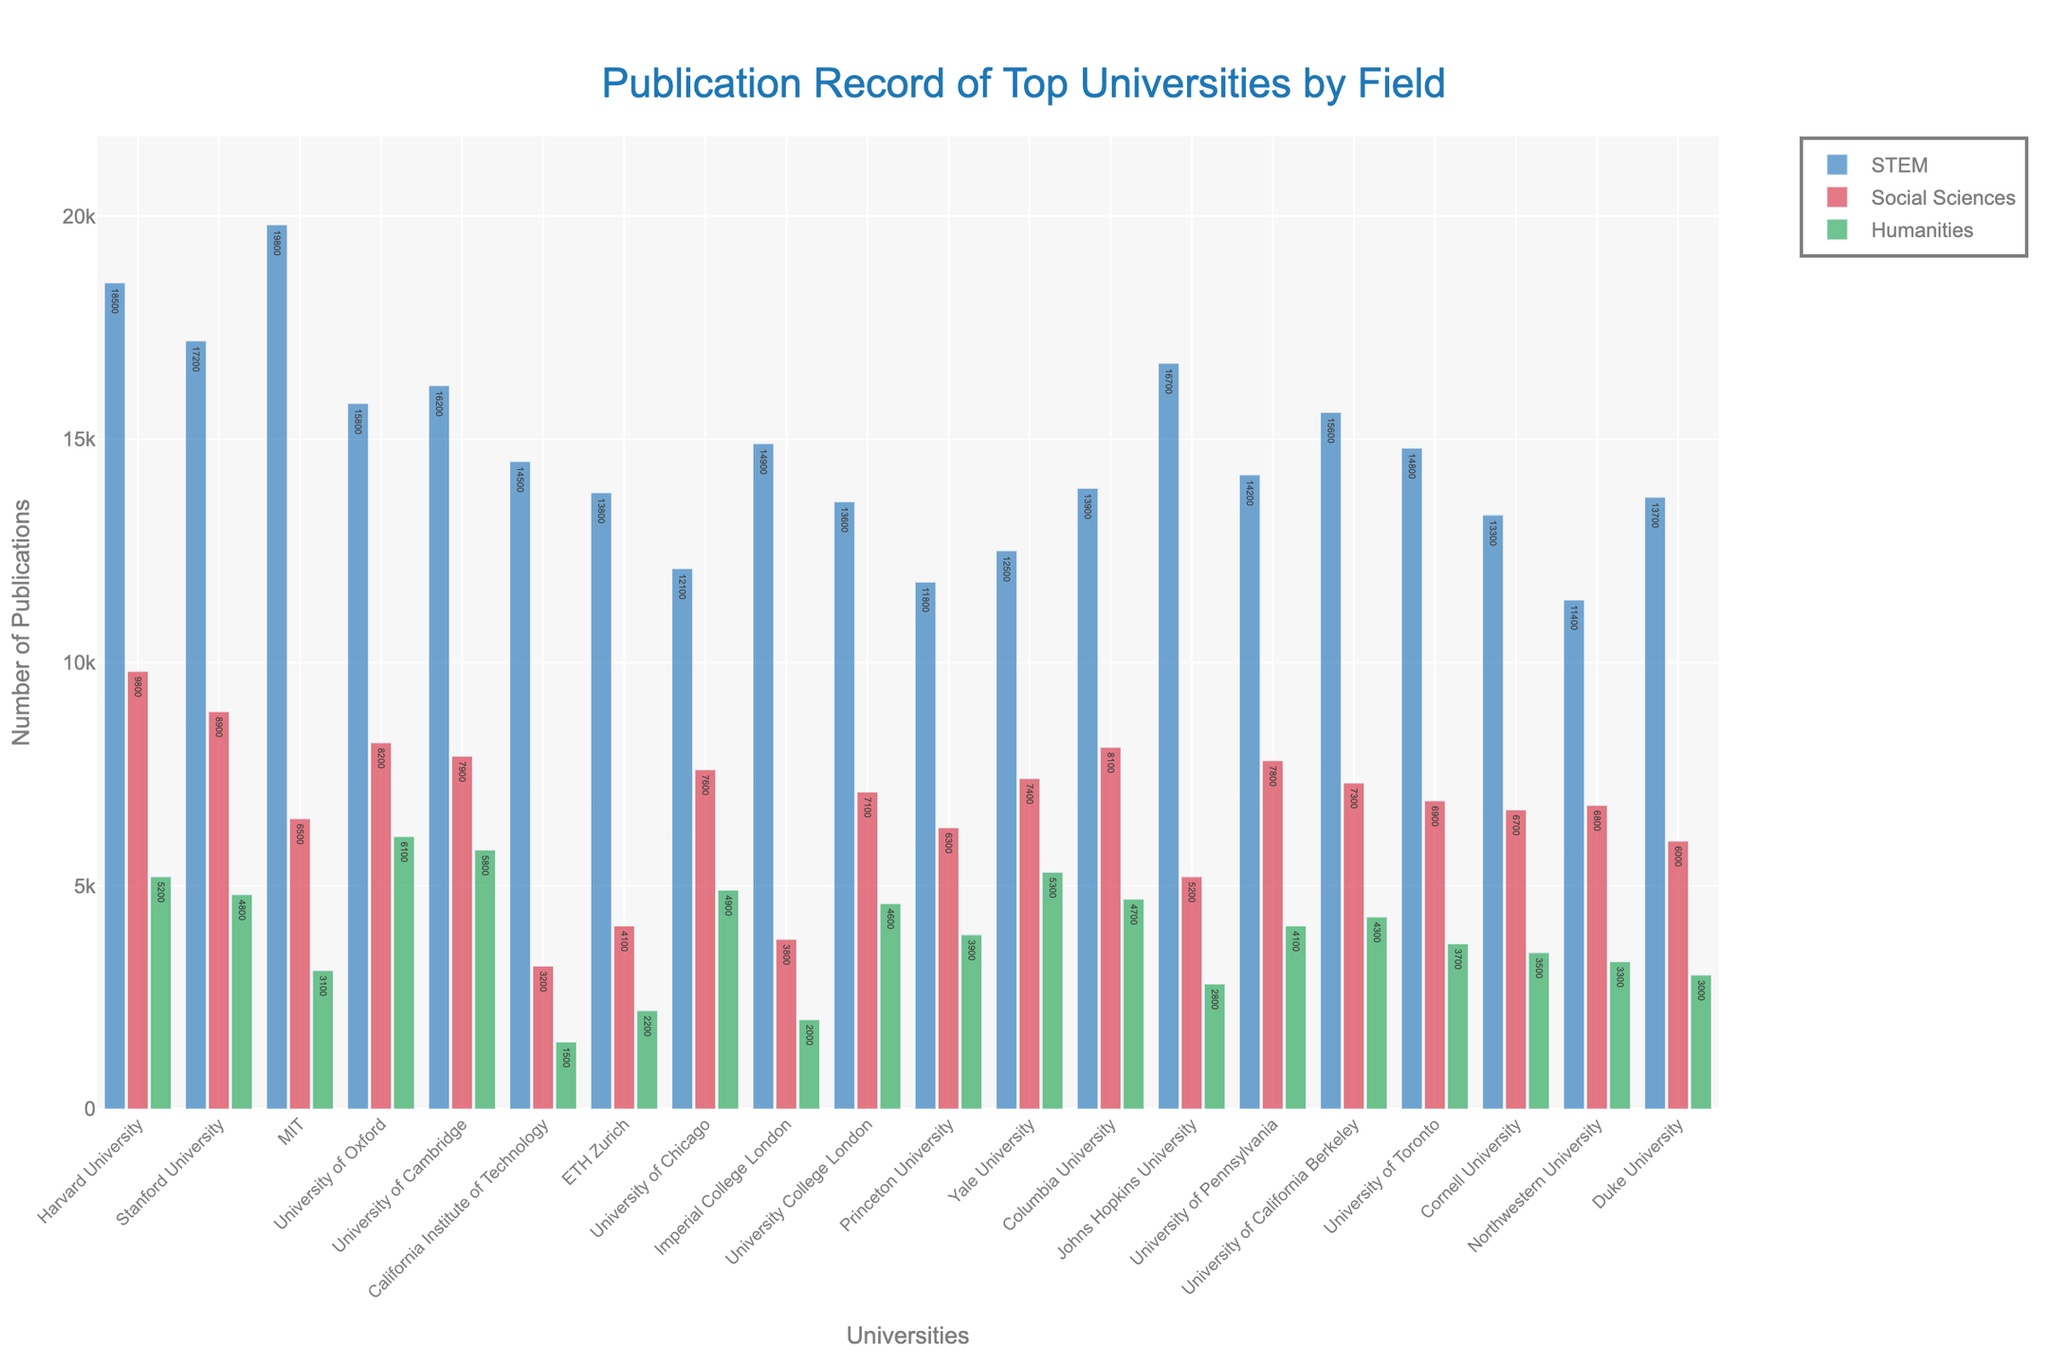Which university has the highest number of STEM publications? By examining the bar chart, the bar representing the number of STEM publications is the highest for MIT.
Answer: MIT Which field has the least publications at the California Institute of Technology? Look at the positions of the bars for each field for Caltech; the Humanities Publications bar is the shortest.
Answer: Humanities What is the sum of STEM and Social Sciences publications for Harvard University? STEM for Harvard University is 18500 and Social Sciences is 9800. Summing these gives: 18500 + 9800 = 28300.
Answer: 28300 Which university has more Social Sciences publications: Stanford or University of Oxford? Compare the heights of the Social Sciences bars for both universities; Stanford's Social Sciences bar is taller than University of Oxford's.
Answer: Stanford Is there a university with more than 20,000 total publications across all fields? If so, which one(s)? Calculate the sum of all fields for each university; none exceed 20,000 total publications.
Answer: None How many more STEM publications does Harvard University have compared to the University of Chicago? Harvard's STEM publications: 18500. University of Chicago's STEM publications: 12100. The difference is: 18500 - 12100 = 6400.
Answer: 6400 Which university has the highest number of publications in Humanities? Look for the tallest bar in the Humanities category, which is for University of Oxford.
Answer: University of Oxford Compare the total number of Social Sciences and Humanities publications: is the sum for Stanford University greater than that of Yale University? For Stanford: 8900 (Social Sciences) + 4800 (Humanities) = 13700. For Yale: 7400 (Social Sciences) + 5300 (Humanities) = 12700. 13700 > 12700.
Answer: Yes How many universities have more than 15,000 STEM publications? Count the universities with STEM bars taller than 15,000. These are Harvard, Stanford, MIT, University of Oxford, University of Cambridge, Johns Hopkins University, University of California Berkeley. There are 7 such universities.
Answer: 7 Which university has the smallest difference between Social Sciences and Humanities publications? Calculate the differences for each university and look for the smallest value. For ETH Zurich: 4100 - 2200 = 1900, which is the smallest difference.
Answer: ETH Zurich 